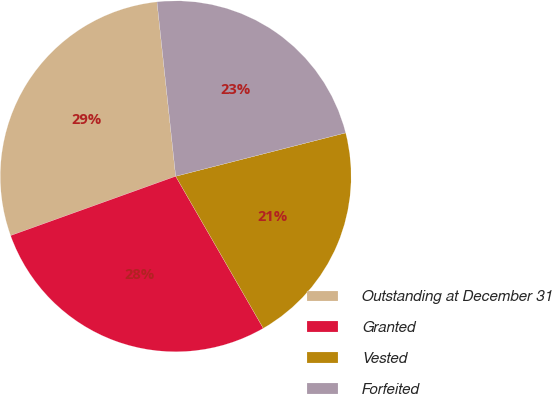Convert chart to OTSL. <chart><loc_0><loc_0><loc_500><loc_500><pie_chart><fcel>Outstanding at December 31<fcel>Granted<fcel>Vested<fcel>Forfeited<nl><fcel>28.79%<fcel>27.83%<fcel>20.66%<fcel>22.72%<nl></chart> 